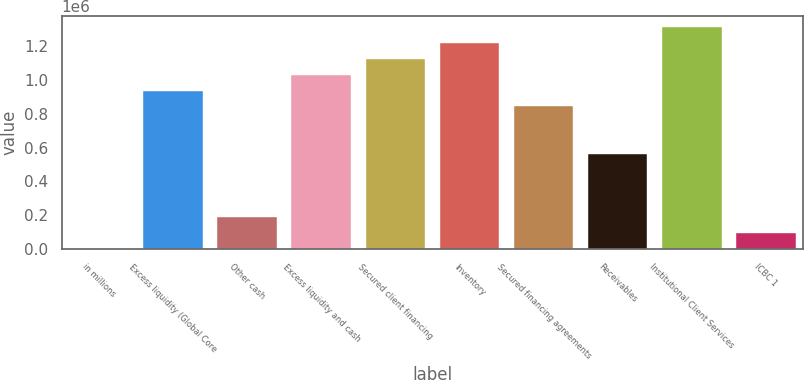<chart> <loc_0><loc_0><loc_500><loc_500><bar_chart><fcel>in millions<fcel>Excess liquidity (Global Core<fcel>Other cash<fcel>Excess liquidity and cash<fcel>Secured client financing<fcel>Inventory<fcel>Secured financing agreements<fcel>Receivables<fcel>Institutional Client Services<fcel>ICBC 1<nl><fcel>2012<fcel>938555<fcel>189321<fcel>1.03221e+06<fcel>1.12586e+06<fcel>1.21952e+06<fcel>844901<fcel>563938<fcel>1.31317e+06<fcel>95666.3<nl></chart> 